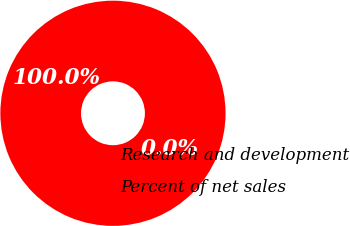Convert chart. <chart><loc_0><loc_0><loc_500><loc_500><pie_chart><fcel>Research and development<fcel>Percent of net sales<nl><fcel>100.0%<fcel>0.0%<nl></chart> 